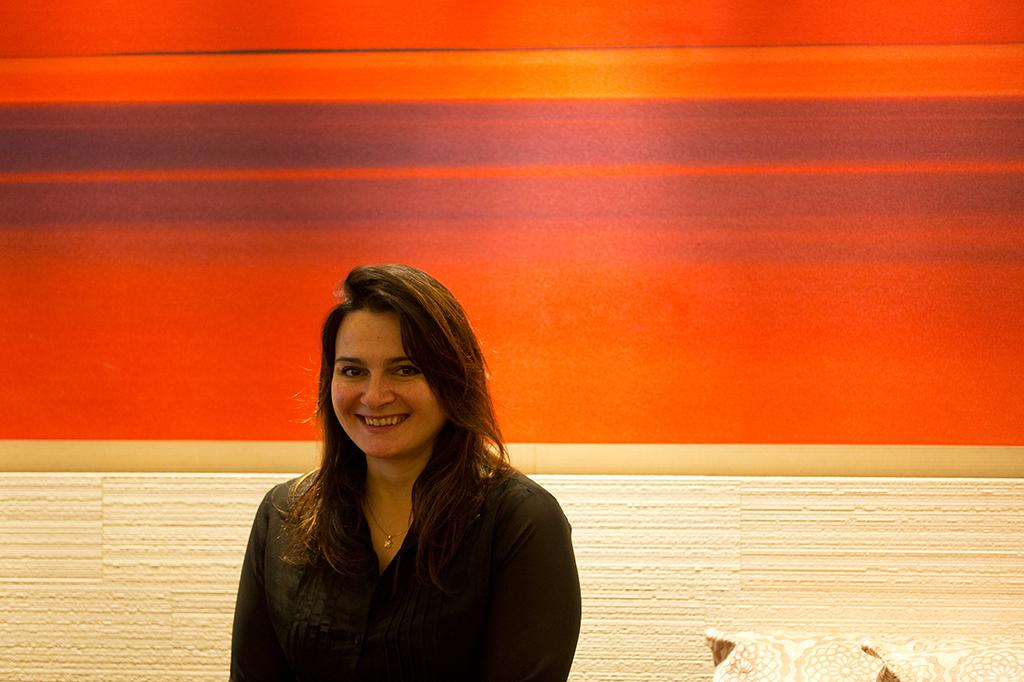What is the main subject in the foreground of the picture? There is a woman in the foreground of the picture. What is the woman's expression in the image? The woman is smiling. What can be seen towards the right side of the image? There are objects towards the right side of the image. What is visible in the background of the image? There is a wall in the background of the image. What is the color of the wall in the image? The wall is in red color. Can you see any fairies flying around the woman in the image? No, there are no fairies visible in the image. Is there a camp set up in the background of the image? No, there is no camp present in the image; only a red wall is visible in the background. 